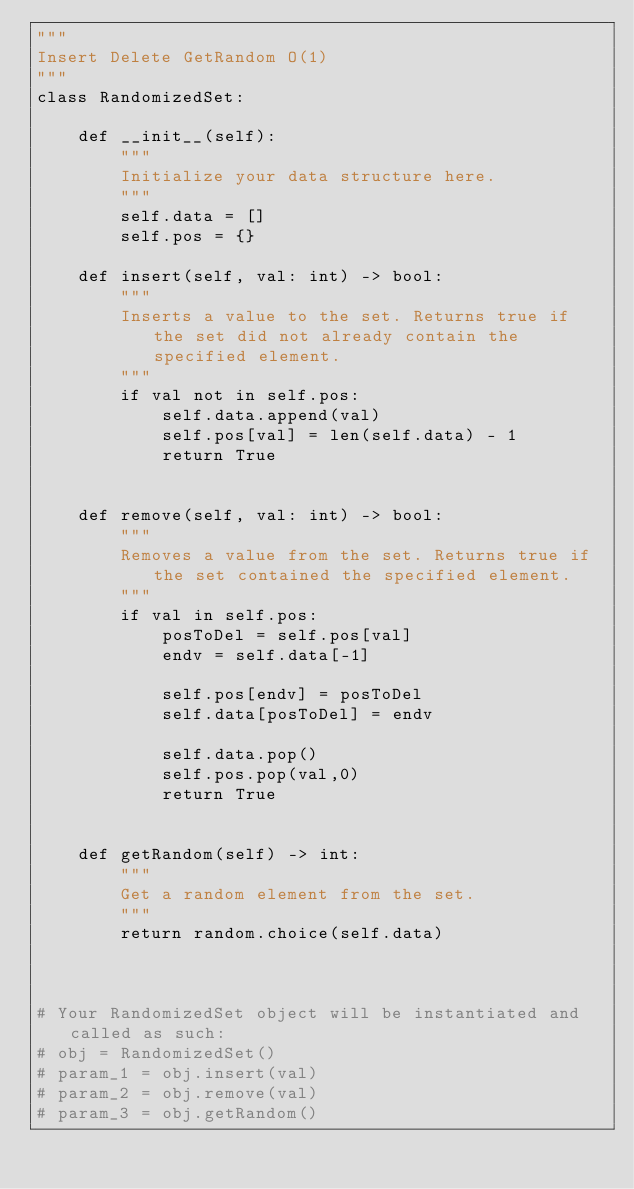Convert code to text. <code><loc_0><loc_0><loc_500><loc_500><_Python_>"""
Insert Delete GetRandom O(1)
"""
class RandomizedSet:

    def __init__(self):
        """
        Initialize your data structure here.
        """
        self.data = []
        self.pos = {}

    def insert(self, val: int) -> bool:
        """
        Inserts a value to the set. Returns true if the set did not already contain the specified element.
        """
        if val not in self.pos:
            self.data.append(val)
            self.pos[val] = len(self.data) - 1
            return True
        

    def remove(self, val: int) -> bool:
        """
        Removes a value from the set. Returns true if the set contained the specified element.
        """
        if val in self.pos:
            posToDel = self.pos[val]
            endv = self.data[-1]
            
            self.pos[endv] = posToDel
            self.data[posToDel] = endv
            
            self.data.pop()
            self.pos.pop(val,0)
            return True
            

    def getRandom(self) -> int:
        """
        Get a random element from the set.
        """
        return random.choice(self.data)



# Your RandomizedSet object will be instantiated and called as such:
# obj = RandomizedSet()
# param_1 = obj.insert(val)
# param_2 = obj.remove(val)
# param_3 = obj.getRandom()</code> 